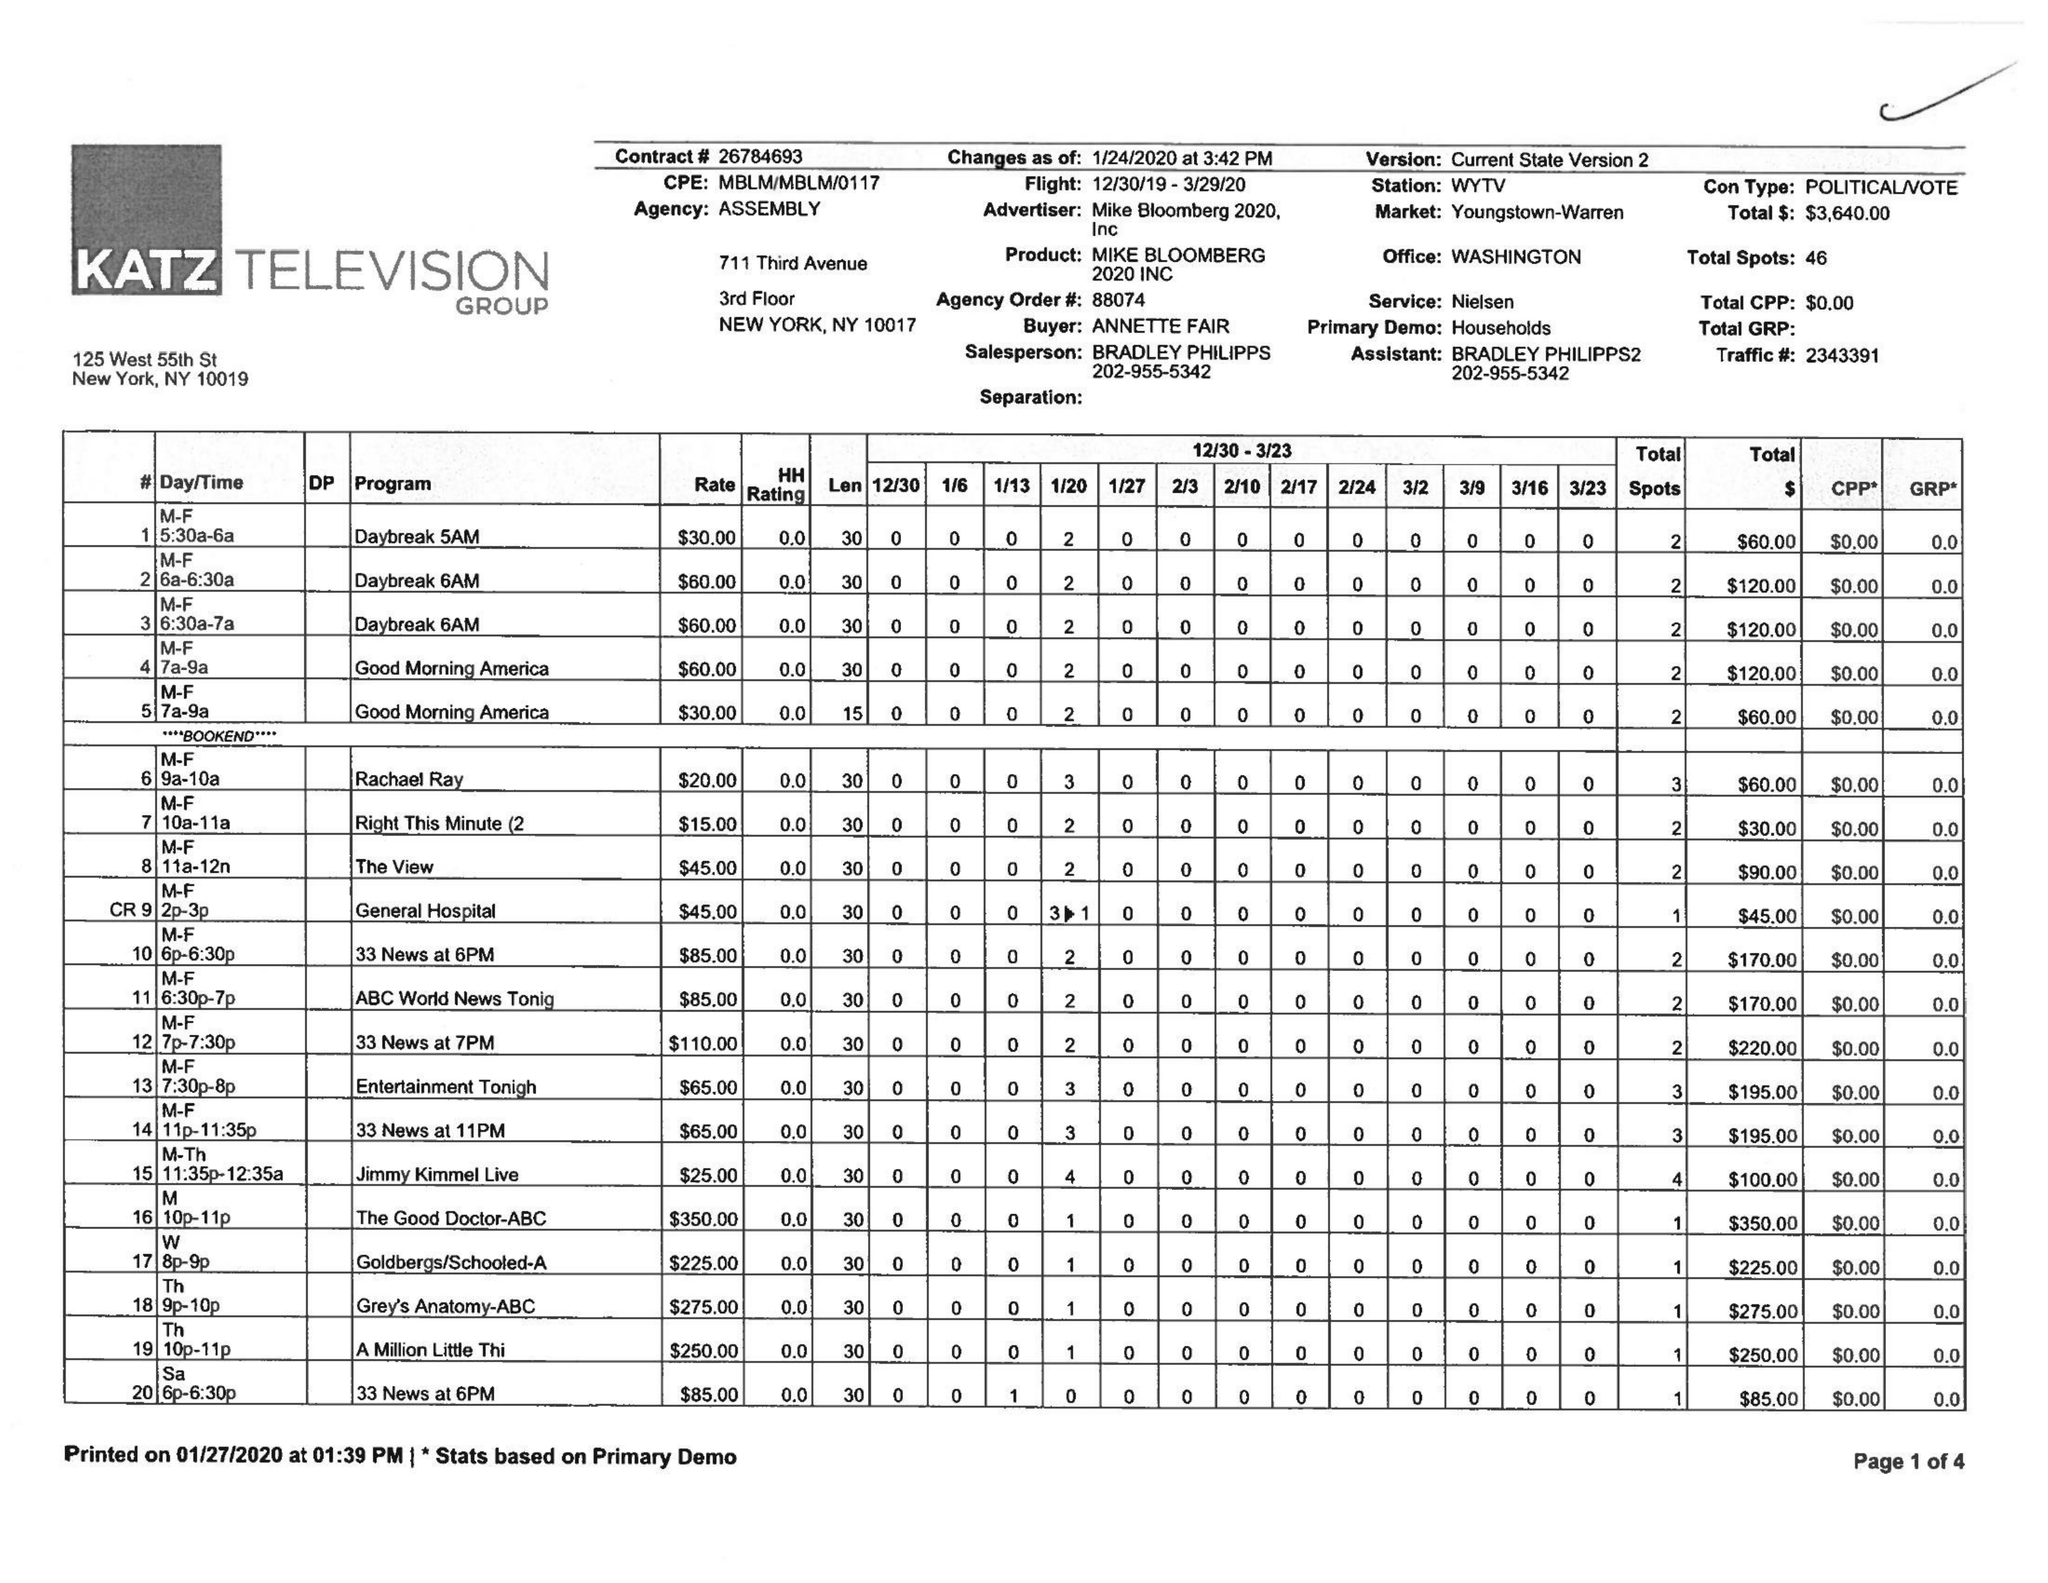What is the value for the gross_amount?
Answer the question using a single word or phrase. 3640.00 